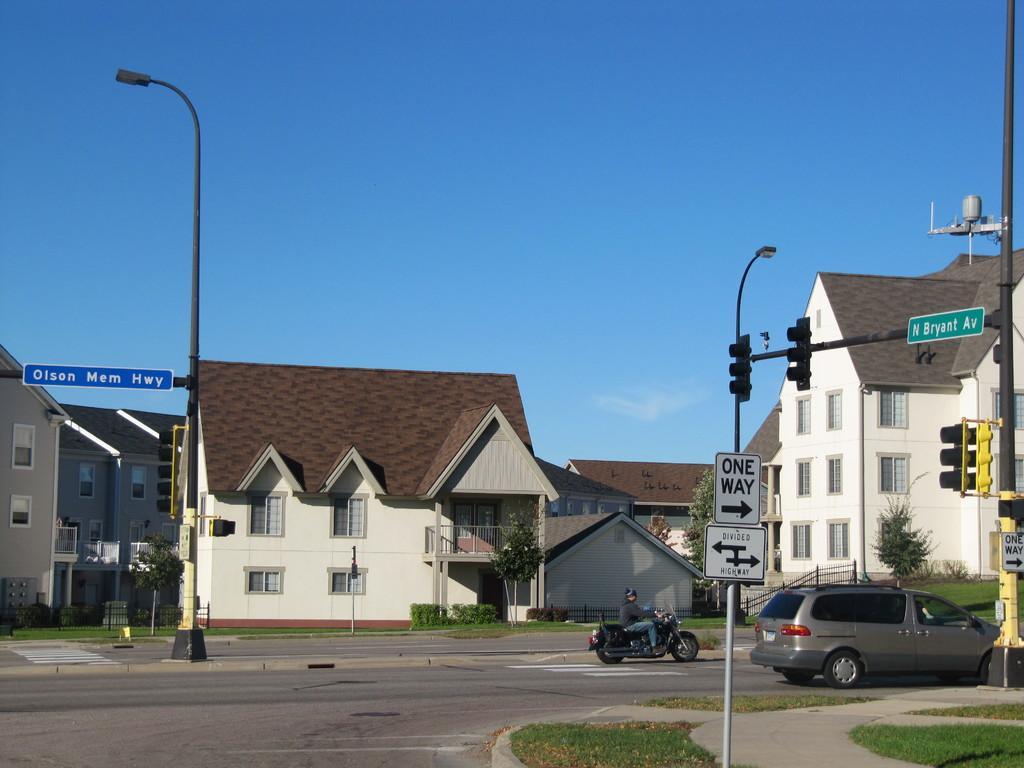Could you give a brief overview of what you see in this image? In this image I can see the person riding the motorbike and car on the road. To the side of the road. I can see the signal pole, boards and the light pole. I can also see many buildings and the plants in the background. I can also see the blue sky. 